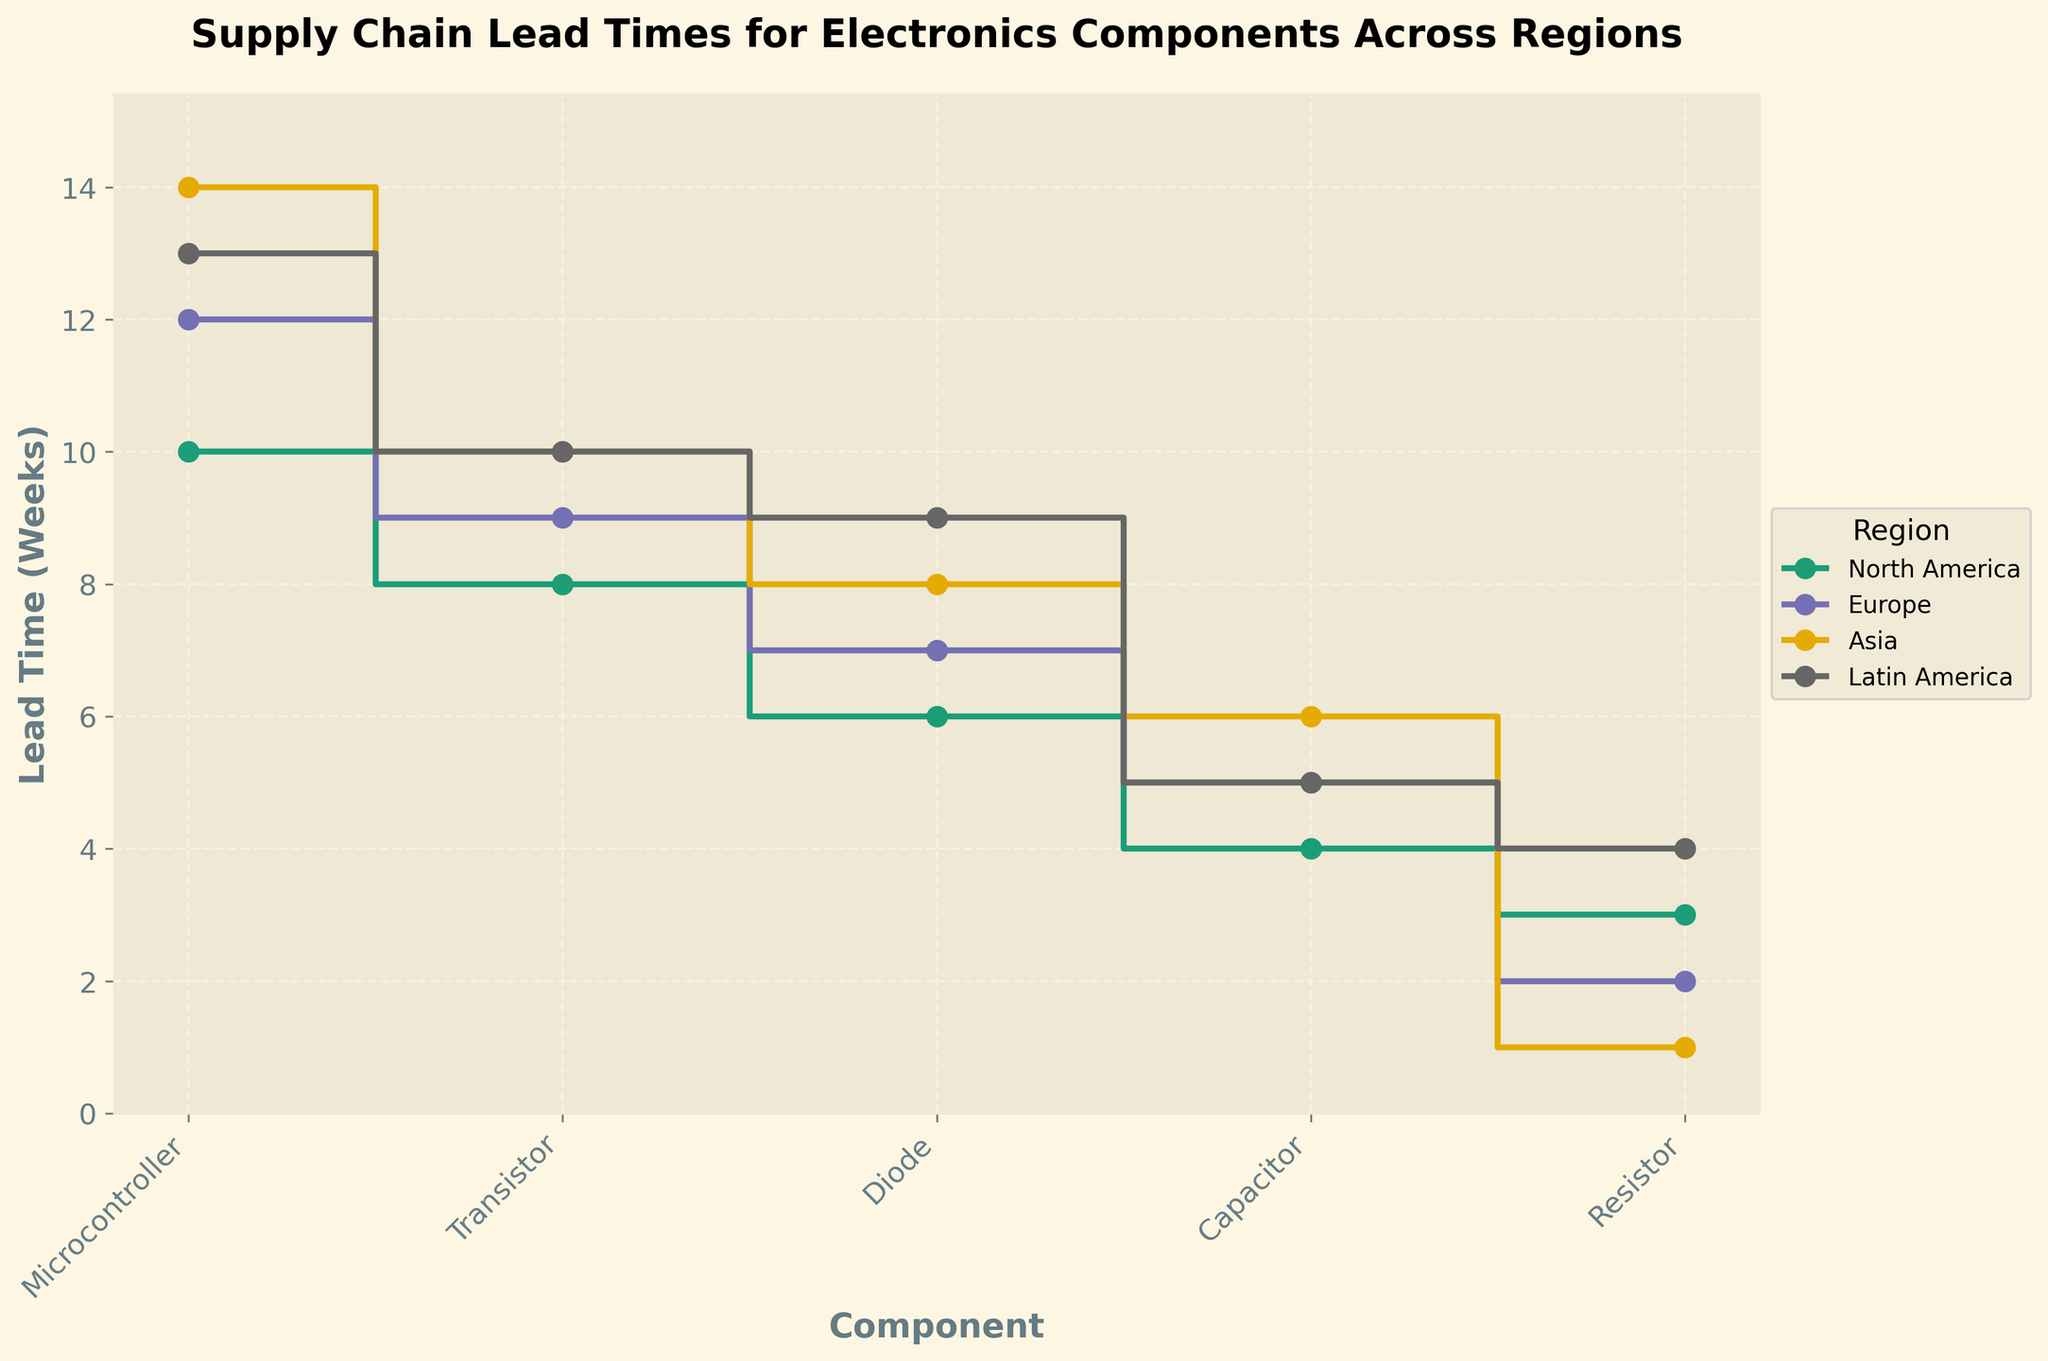Which region has the longest lead time for microcontrollers? By looking at the plot, identify the line with the highest value for microcontrollers on the x-axis.
Answer: Asia What is the shortest lead time for resistors, and which region does it belong to? Find the lowest value among the plotted points for resistors and identify the corresponding region.
Answer: 1 week, Asia How does the lead time for capacitors in North America compare to Europe? Compare the capacitor lead times for North America and Europe regions on the plot.
Answer: 4 weeks in North America, 5 weeks in Europe Which component shows the greatest variation in lead time across the different regions? Examine the range of lead times for each component across all regions. The component with the largest difference between the maximum and minimum values represents the greatest variation.
Answer: Microcontroller Arrange the regions in descending order based on the lead time for transistors. Observe the lead time values for transistors in each region and arrange them in descending order.
Answer: Asia, Latin America, Europe, North America What is the average lead time for diodes in all regions? Sum the lead times for diodes across all regions and divide by the number of regions. The values to consider are: 6, 7, 8, and 9. (6 + 7 + 8 + 9) / 4 = 30 / 4 = 7.5 weeks
Answer: 7.5 weeks Is the lead time for capacitors in Latin America higher or lower than in Asia? Compare the lead time for capacitors between Latin America and Asia on the plot.
Answer: Lower (5 weeks in Latin America vs. 6 weeks in Asia) Which component has a consistently similar lead time across all regions? Look for the component with minimal variation in lead times across different regions.
Answer: Capacitors For which component do all regions have lead times below 10 weeks? Find the component for which all regions' lead times do not exceed 10 weeks.
Answer: Resistor What is the lead time for diodes in Latin America, and how does it compare to the lead time in Europe? Check the lead time for diodes in both Latin America and Europe and compare them.
Answer: 9 weeks in Latin America, 7 weeks in Europe 